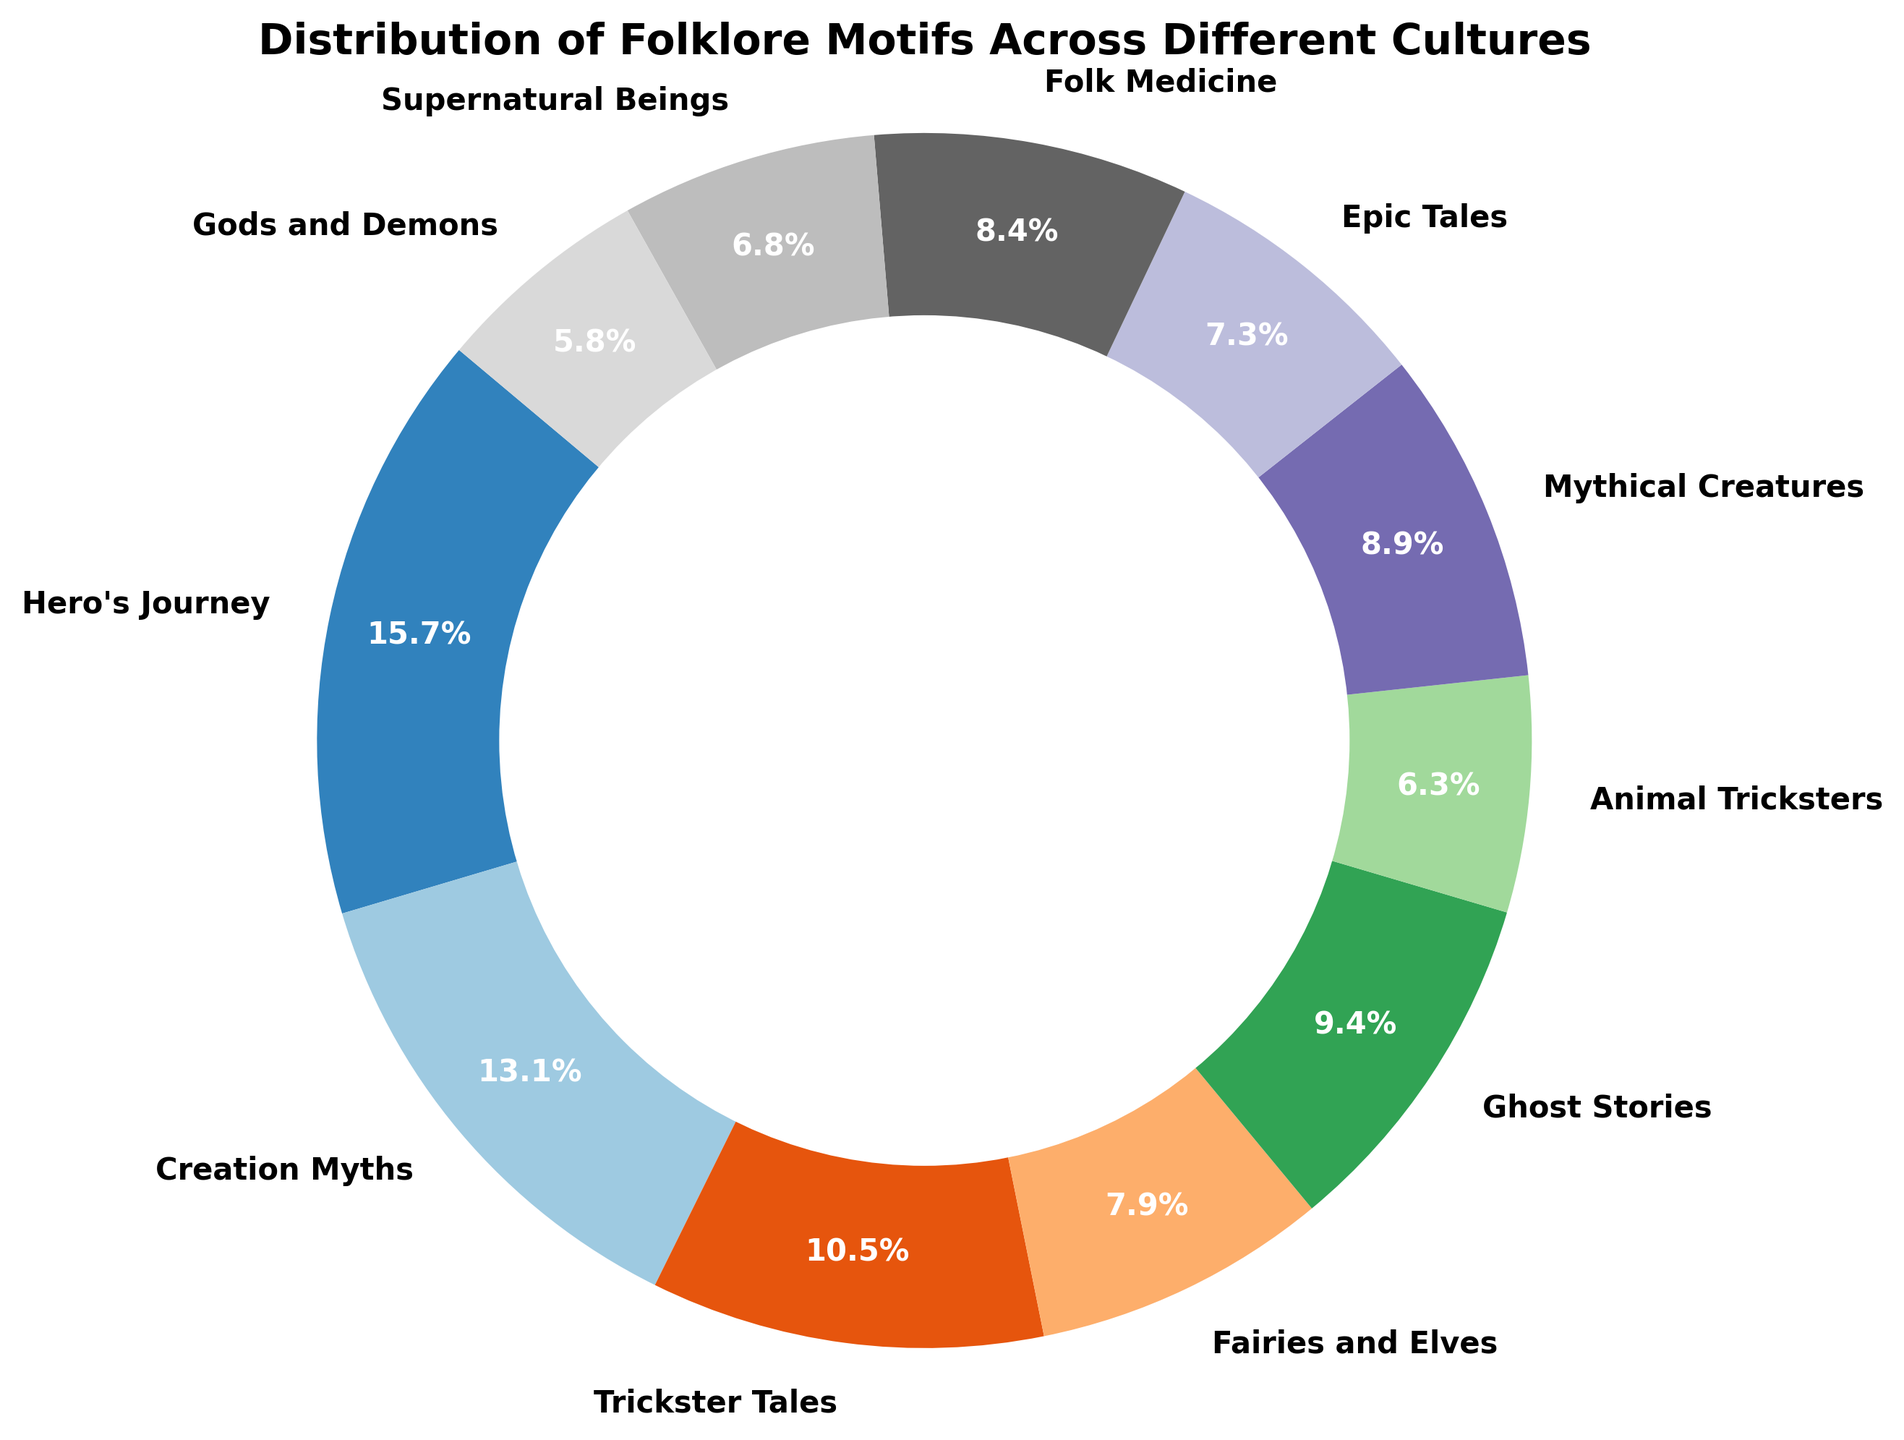What's the largest folklore motif category shown in the pie chart? The largest folklore motif category is the one with the highest percentage. By looking at the pie chart, the biggest wedge represents the "Hero's Journey" with 300 counts, which is reflected by the highest percentage.
Answer: Hero's Journey Which folklore motif has a higher count: Trickster Tales or Ghost Stories? By referring to the pie chart, the data shows the exact counts and percentages of each motif. "Trickster Tales" has 200 counts while "Ghost Stories" has 180 counts, making "Trickster Tales" higher in count.
Answer: Trickster Tales What is the total count of European folklore motifs? To find the total count of European folklore motifs, sum up the counts for "Fairies and Elves" (150) and "Mythical Creatures" (170). Therefore, 150 + 170 = 320.
Answer: 320 If we combine the counts of Middle Eastern and African motifs, do they surpass the count of Worldwide motifs? First, sum the counts for Middle Eastern ("Epic Tales" with 140) and African ("Trickster Tales" with 200), resulting in 140 + 200 = 340. Compare this to the count of Worldwide ("Hero's Journey" with 300); 340 > 300 means they surpass it.
Answer: Yes What color represents "Gods and Demons" in the pie chart? The "Gods and Demons" wedge can be identified by its unique color in the pie chart, which visually distinguishes it and corresponds to "Hindu". The exact label "Gods and Demons" also helps to pinpoint its color, which is typically displayed next to its wedge.
Answer: Identifiable by viewing the chart Which motif category has the second highest count after "Hero's Journey"? After identifying "Hero's Journey" as the category with the highest count (300), the next highest can be determined by comparing other wedges. "Creation Myths" has the second largest wedge with 250 counts.
Answer: Creation Myths What is the combined percentage of the categories "Animal Tricksters" and "Supernatural Beings"? Calculate the individual percentages of "Animal Tricksters" (120) and "Supernatural Beings" (130) relative to the total count. Summing these percentages provides the combined value. Both are definable from visual inspection.
Answer: Calculable by summing their percentages What is the ratio of Worldwide motifs to Indigenous Cultures motifs? To find the ratio, compare the counts: Worldwide ("Hero's Journey" with 300) to Indigenous Cultures ("Folk Medicine" with 160). Thus, the ratio is 300:160, which simplifies to 15:8.
Answer: 15:8 Which motifs account for less than 10% individually, and what are they? By observing the size of wedges and the percentage labels, those representing less than 10% can be determined. Both "Gods and Demons" and "Supernatural Beings" have counts and respective percentages falling below 10%.
Answer: Gods and Demons, Supernatural Beings Which culture's motifs represent the smallest count and what is it? By looking at the pie chart, it's clear from the data that the wedge representing the smallest count is labeled "Gods and Demons" with a count of 110, attributed to Hindu culture.
Answer: Hindu 